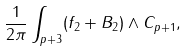<formula> <loc_0><loc_0><loc_500><loc_500>\frac { 1 } { 2 \pi } \int _ { p + 3 } ( f _ { 2 } + B _ { 2 } ) \wedge C _ { p + 1 } ,</formula> 